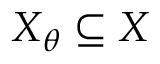<formula> <loc_0><loc_0><loc_500><loc_500>X _ { \theta } \subseteq X</formula> 